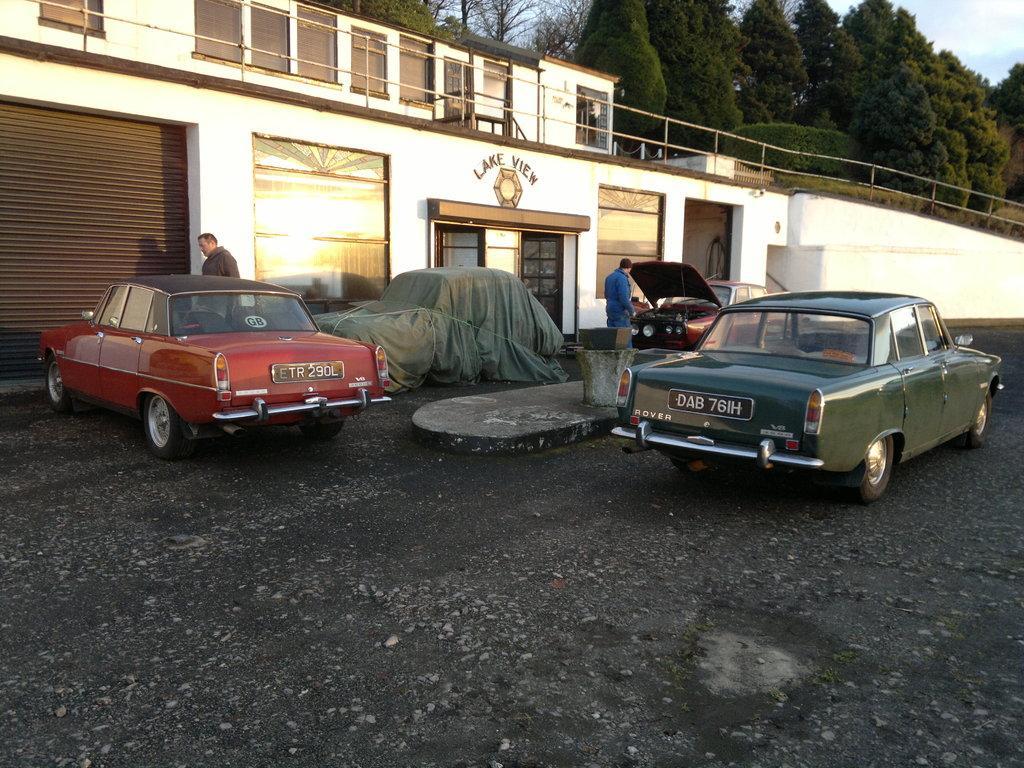How would you summarize this image in a sentence or two? In this image we can see a group of cars parked on the ground, two persons are standing on the floor. One person is wearing a blue dress. In the center of the image we can see a building with metal railing, windows, door and some text on it. In the background we can see a group of trees and the sky. 